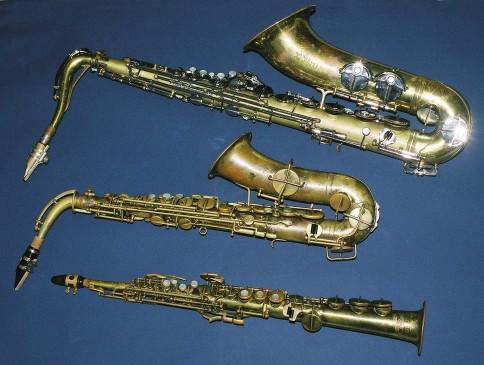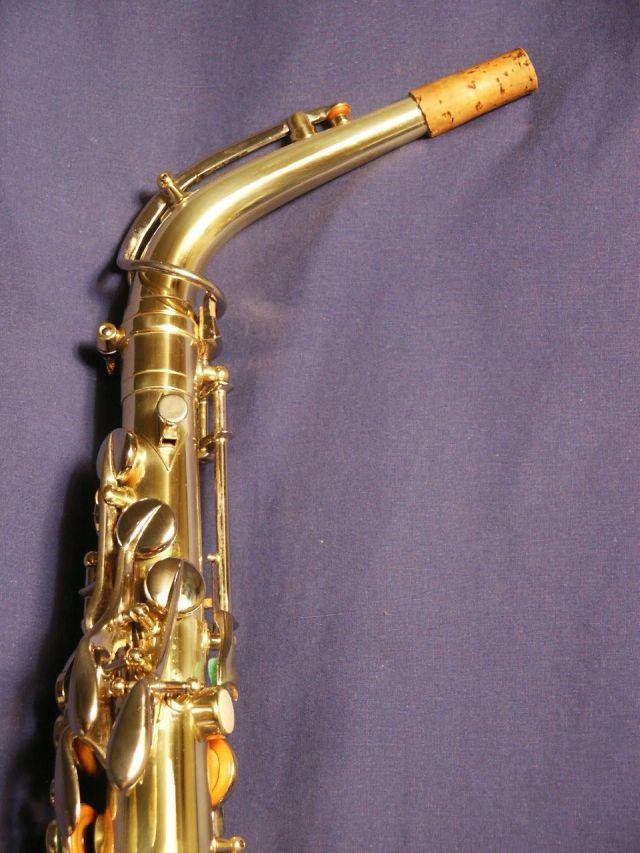The first image is the image on the left, the second image is the image on the right. For the images displayed, is the sentence "There are exactly two saxophones." factually correct? Answer yes or no. No. The first image is the image on the left, the second image is the image on the right. Evaluate the accuracy of this statement regarding the images: "One image contains a single gold saxophone with its mouthpiece at the top, and the other image shows three saxophones, at least two of them with curved bell ends.". Is it true? Answer yes or no. Yes. 